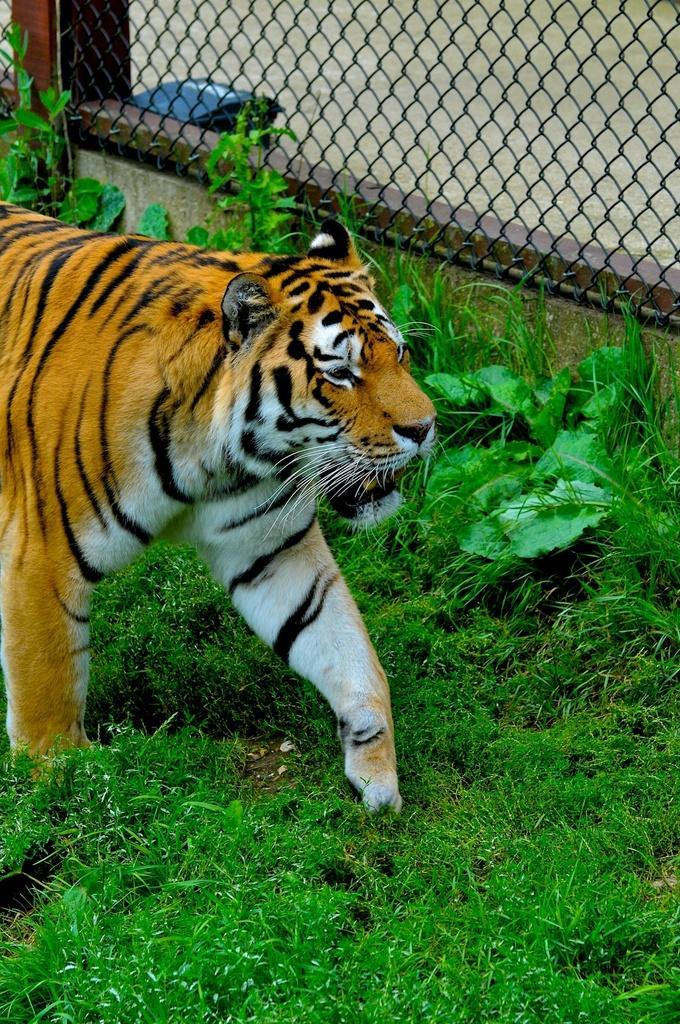Can you describe this image briefly? This is the picture of a tiger which is on the grass floor, to the side there is a fencing and some plants around. 